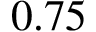Convert formula to latex. <formula><loc_0><loc_0><loc_500><loc_500>0 . 7 5</formula> 